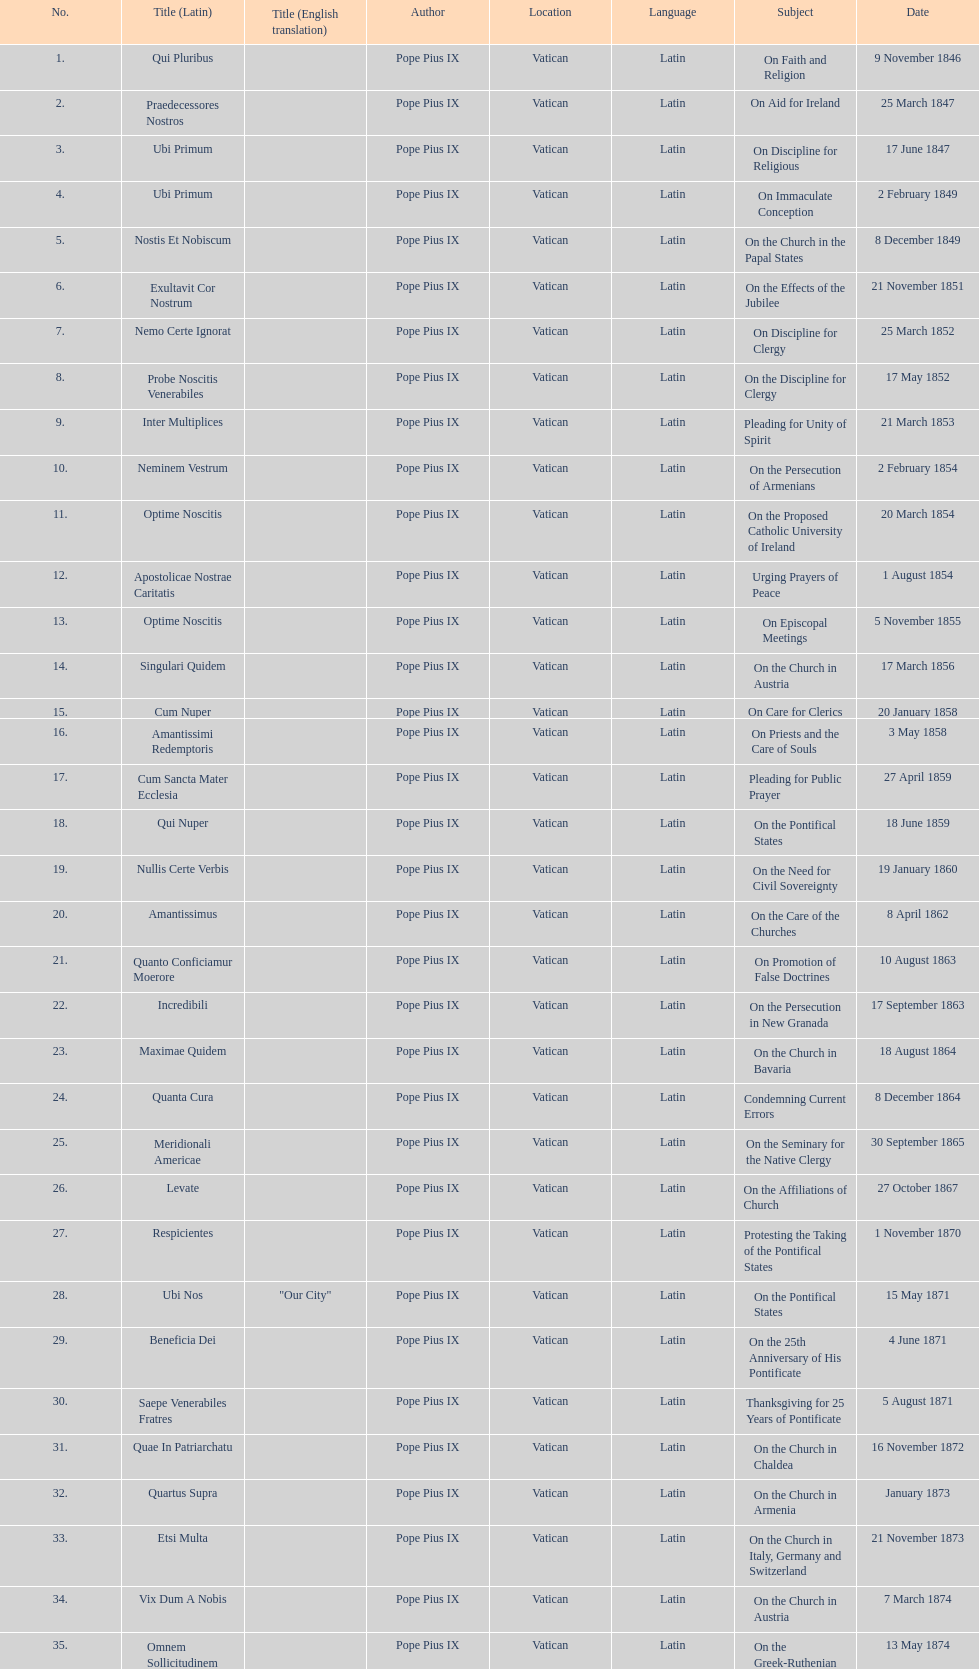Latin title of the encyclical before the encyclical with the subject "on the church in bavaria" Incredibili. 